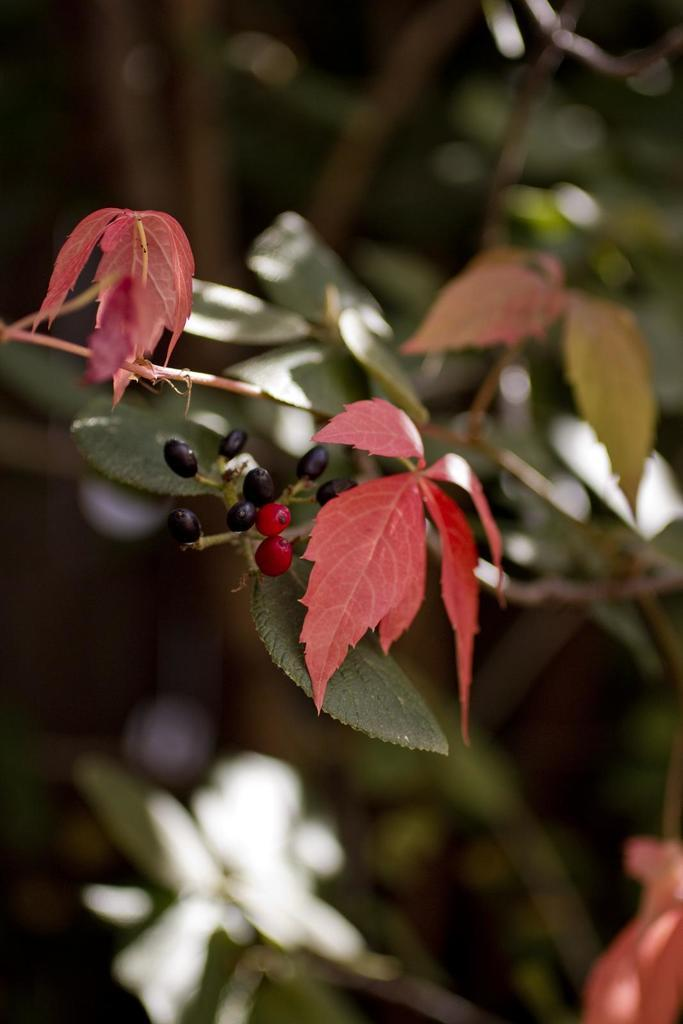What type of plant parts can be seen in the image? There are leaves and stems in the image. What type of fruit or produce is visible in the image? There are berries in the image. What type of clouds can be seen in the image? There are no clouds present in the image; it features leaves, stems, and berries. What type of learning material is visible in the image? There is no learning material present in the image. 